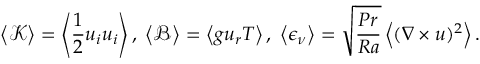<formula> <loc_0><loc_0><loc_500><loc_500>\left \langle \mathcal { K } \right \rangle = \left \langle \frac { 1 } { 2 } u _ { i } u _ { i } \right \rangle , \, \left \langle \mathcal { B } \right \rangle = \left \langle g u _ { r } T \right \rangle , \, \left \langle \epsilon _ { \nu } \right \rangle = \sqrt { \frac { P r } { R a } } \left \langle ( \nabla \times u ) ^ { 2 } \right \rangle .</formula> 